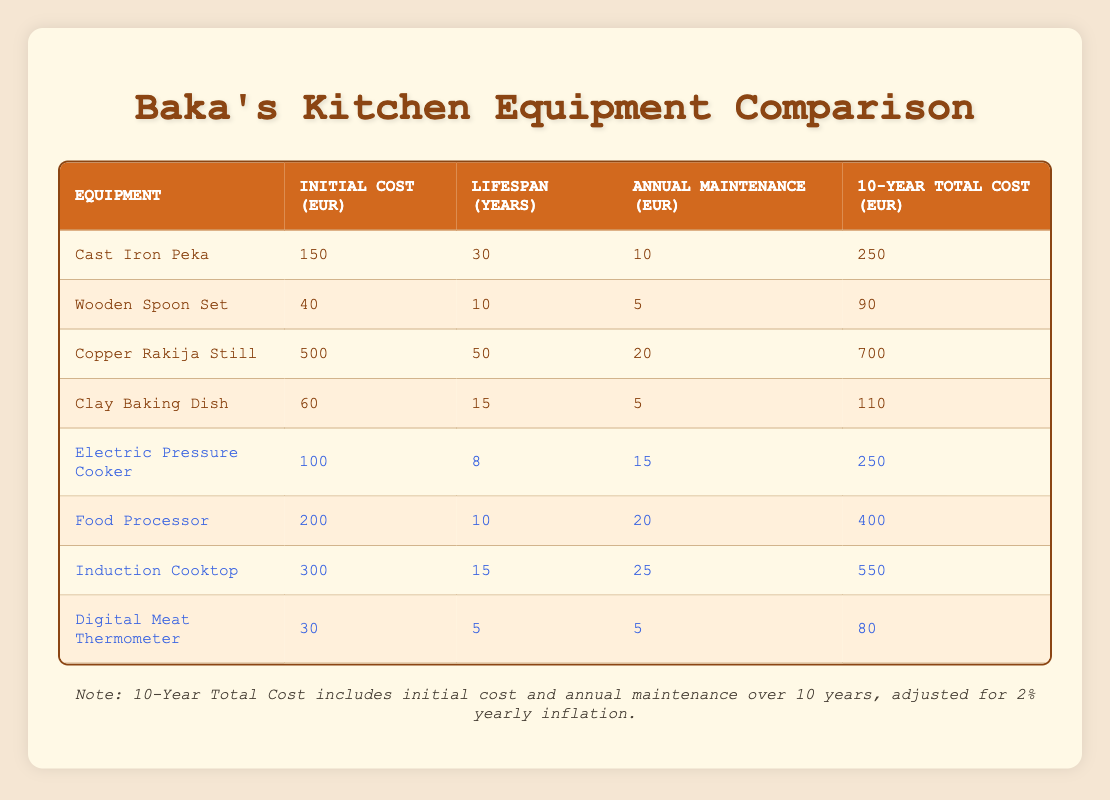What is the initial cost of the Copper Rakija Still? The initial cost is listed directly in the row corresponding to the Copper Rakija Still, which shows 500 EUR.
Answer: 500 EUR How much does the Electric Pressure Cooker cost to maintain over 10 years? The Electric Pressure Cooker has an annual maintenance cost of 15 EUR. Over 10 years, the total maintenance cost is calculated as 15 EUR * 10 years = 150 EUR.
Answer: 150 EUR What is the total cost of the Cast Iron Peka over its lifespan in the table? The table shows the initial cost of the Cast Iron Peka as 150 EUR and an annual maintenance cost of 10 EUR. Over 10 years, the maintenance cost is 10 EUR * 10 years = 100 EUR. The total cost over 10 years is the sum of these two amounts: 150 EUR + 100 EUR = 250 EUR.
Answer: 250 EUR Is the annual maintenance cost of the Induction Cooktop higher than that of the Digital Meat Thermometer? The Induction Cooktop has an annual maintenance cost of 25 EUR, while the Digital Meat Thermometer has an annual maintenance cost of 5 EUR. Therefore, 25 EUR is greater than 5 EUR, making this statement true.
Answer: Yes Which equipment has the longest lifespan and what is that lifespan? The equipment with the longest lifespan is the Copper Rakija Still, which has a lifespan of 50 years. To find this, we compare the lifespan of all equipment listed in the table.
Answer: 50 years 